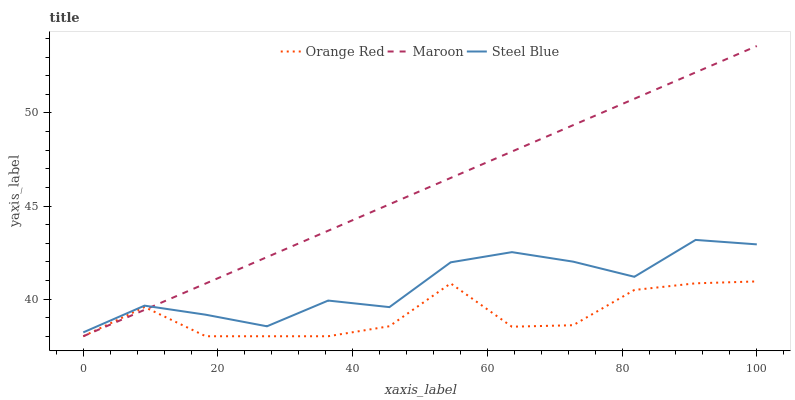Does Orange Red have the minimum area under the curve?
Answer yes or no. Yes. Does Maroon have the maximum area under the curve?
Answer yes or no. Yes. Does Steel Blue have the minimum area under the curve?
Answer yes or no. No. Does Steel Blue have the maximum area under the curve?
Answer yes or no. No. Is Maroon the smoothest?
Answer yes or no. Yes. Is Orange Red the roughest?
Answer yes or no. Yes. Is Steel Blue the smoothest?
Answer yes or no. No. Is Steel Blue the roughest?
Answer yes or no. No. Does Orange Red have the lowest value?
Answer yes or no. Yes. Does Steel Blue have the lowest value?
Answer yes or no. No. Does Maroon have the highest value?
Answer yes or no. Yes. Does Steel Blue have the highest value?
Answer yes or no. No. Is Orange Red less than Steel Blue?
Answer yes or no. Yes. Is Steel Blue greater than Orange Red?
Answer yes or no. Yes. Does Maroon intersect Orange Red?
Answer yes or no. Yes. Is Maroon less than Orange Red?
Answer yes or no. No. Is Maroon greater than Orange Red?
Answer yes or no. No. Does Orange Red intersect Steel Blue?
Answer yes or no. No. 